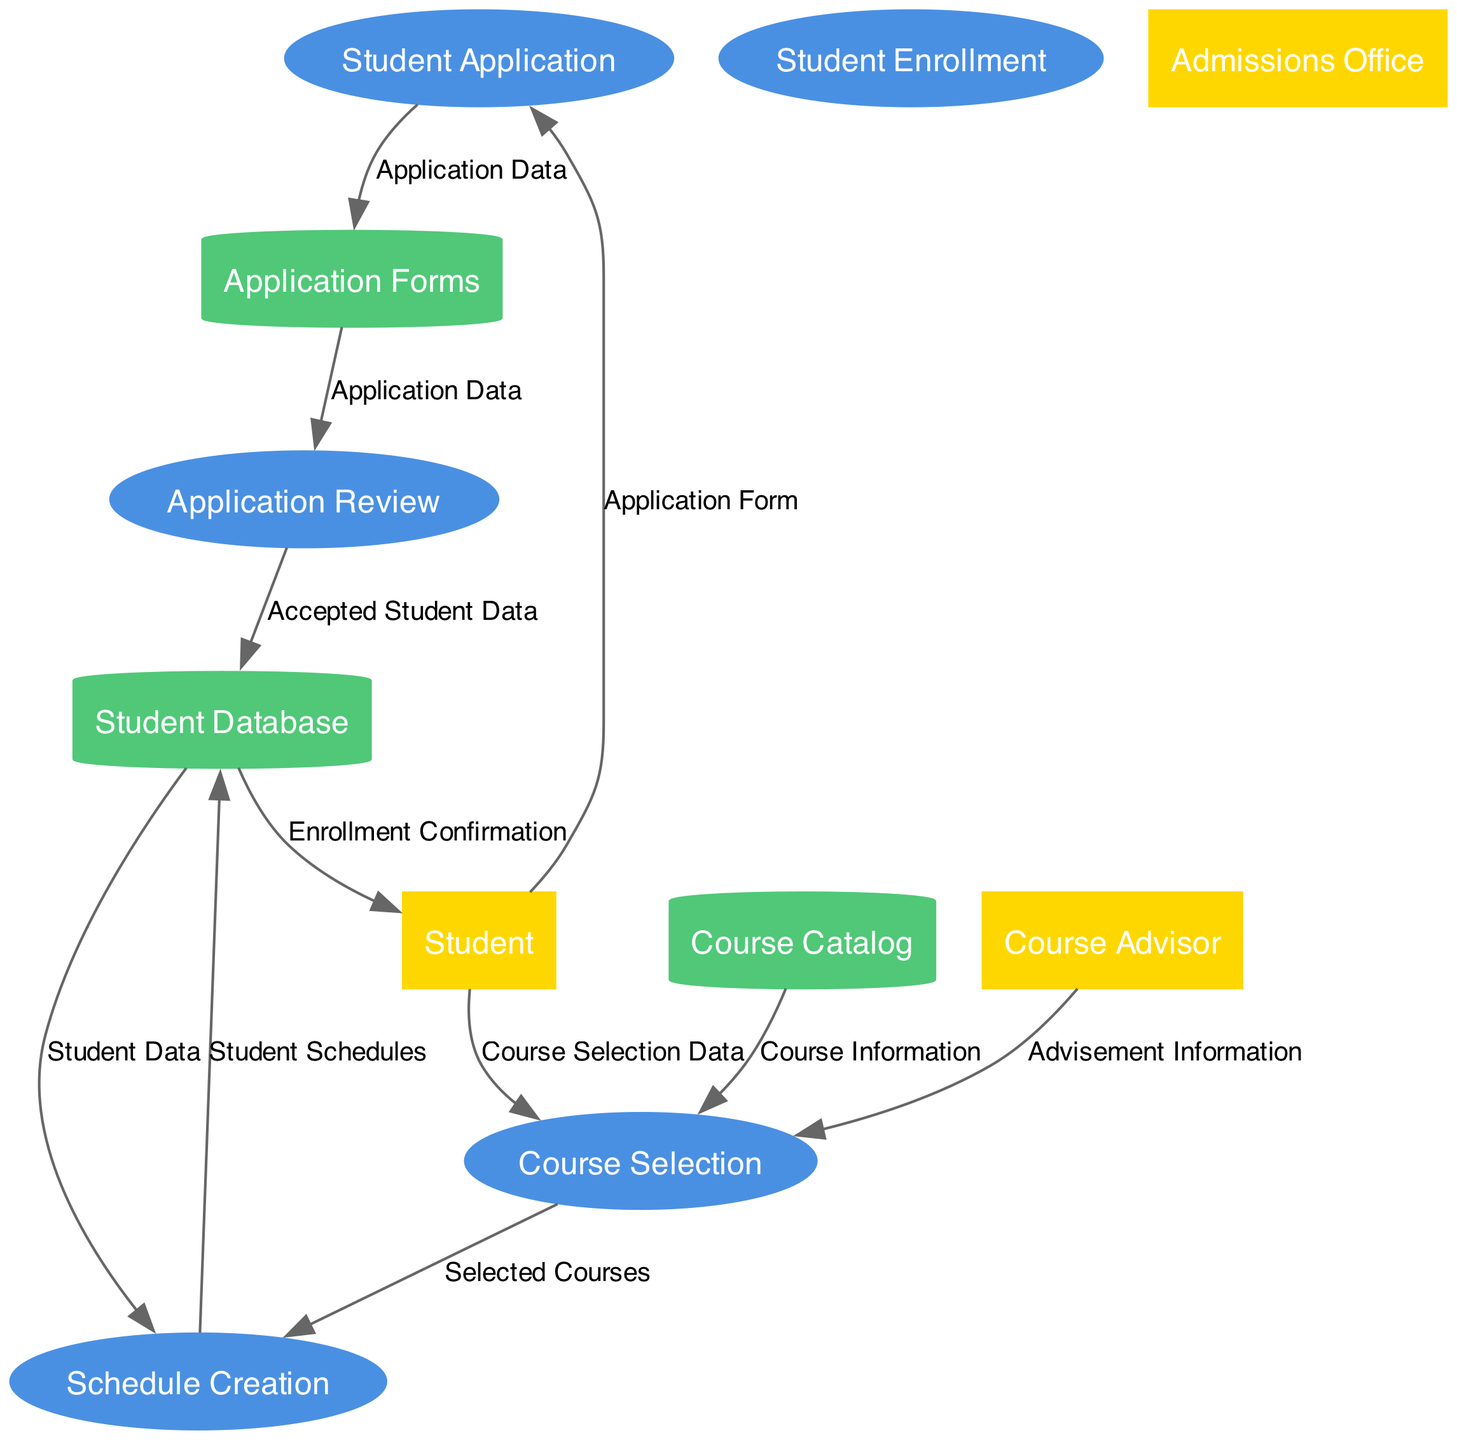What is the first process in the diagram? The first process listed in the data flow diagram is "Student Application", which signifies the initial step in the enrollment process.
Answer: Student Application How many data stores are present in the diagram? According to the data provided, there are three data stores: "Student Database", "Course Catalog", and "Application Forms". Adding these, we confirm there are three data stores in total.
Answer: 3 What type of information does the 'Course Selection' process receive from the 'Course Catalog'? The 'Course Selection' process receives "Course Information" from the 'Course Catalog', which helps students to select courses they wish to enroll in.
Answer: Course Information Which external entity contributes to the 'Course Selection' process? The external entity that contributes to the 'Course Selection' process is the "Course Advisor", who provides "Advisement Information" to assist students.
Answer: Course Advisor What is the last process that a student engages in according to the diagram? The last process a student engages in is "Schedule Creation", which occurs after the course selection process to organize their schedule based on selected courses.
Answer: Schedule Creation What data flows from 'Application Review' to 'Student Database'? The data that flows from 'Application Review' to 'Student Database' is the "Accepted Student Data", which updates the student database with information on students who have been accepted.
Answer: Accepted Student Data Which process does the 'Student' send data to initiate their enrollment? The 'Student' sends an "Application Form" to the "Student Application" process to initiate their enrollment into the university.
Answer: Student Application How does the 'Schedule Creation' process receive data regarding student information? The 'Schedule Creation' process receives "Student Data" from the 'Student Database', which contains necessary information to create schedules for students based on their courses.
Answer: Student Data 